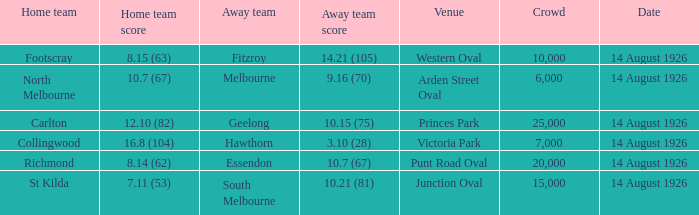What is the sum of all the crowds that watched North Melbourne at home? 6000.0. 